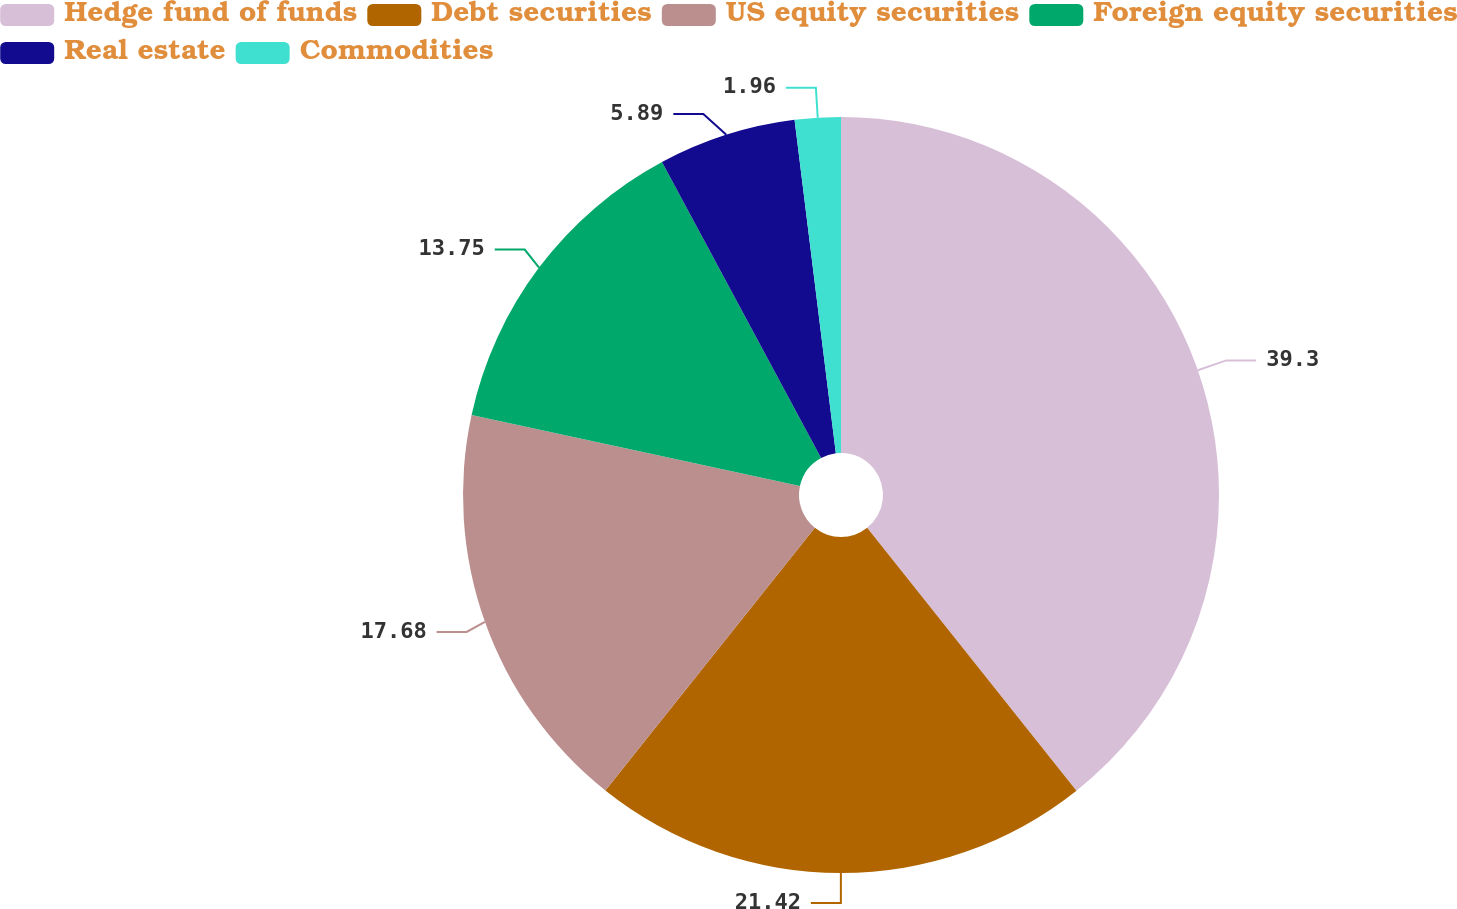<chart> <loc_0><loc_0><loc_500><loc_500><pie_chart><fcel>Hedge fund of funds<fcel>Debt securities<fcel>US equity securities<fcel>Foreign equity securities<fcel>Real estate<fcel>Commodities<nl><fcel>39.29%<fcel>21.41%<fcel>17.68%<fcel>13.75%<fcel>5.89%<fcel>1.96%<nl></chart> 